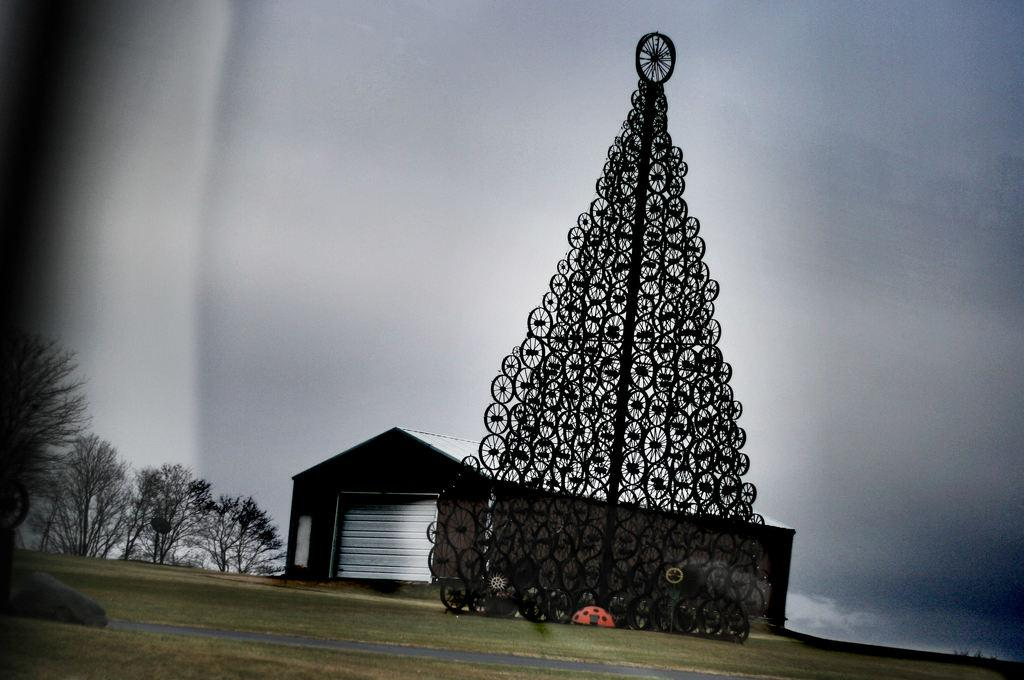What is the main subject in the center of the image? There is a structure in the center of the image. What type of vegetation is present at the bottom of the image? There is grass at the bottom of the image. What type of building can be seen in the image? There is a house in the image. What other natural elements are present in the image? There are trees in the image. What is visible at the top of the image? There is sky visible at the top of the image. Where is the crayon being used during the meeting in the image? There is no meeting or crayon present in the image. 